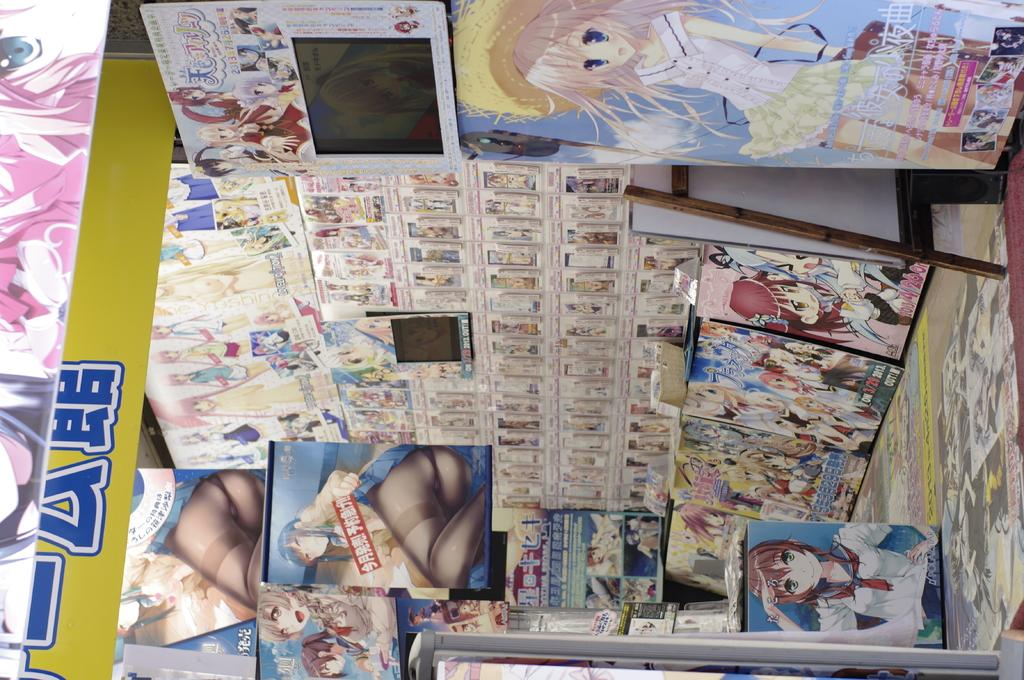What is present on the wall in the image? There are cartoon stickers on the wall in the image. What can be seen on the screens in the image? The facts do not specify what is on the screens, so we cannot answer that question definitively. What is the best route to take to reach the rhythm in the image? There is no mention of a rhythm or a route in the image, so we cannot answer that question. 